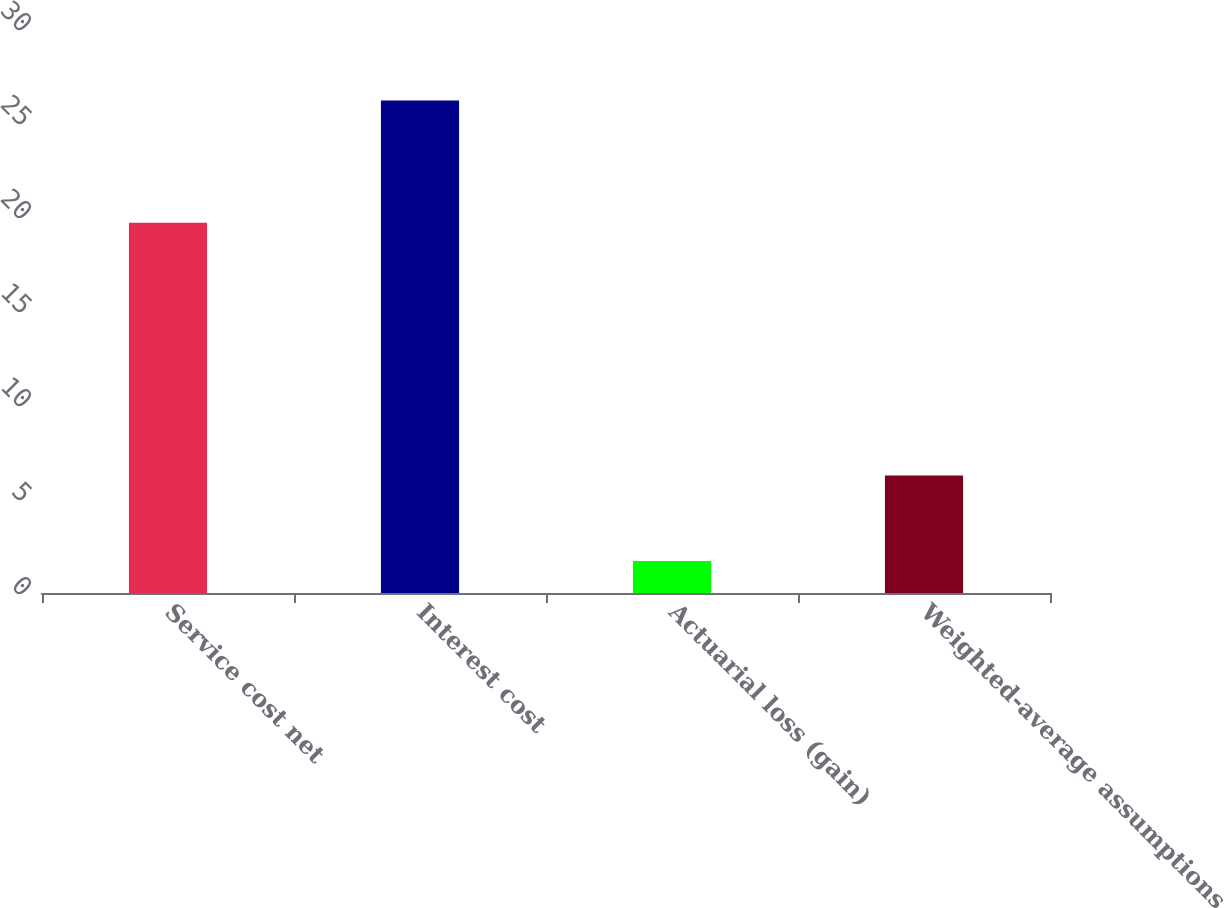Convert chart to OTSL. <chart><loc_0><loc_0><loc_500><loc_500><bar_chart><fcel>Service cost net<fcel>Interest cost<fcel>Actuarial loss (gain)<fcel>Weighted-average assumptions<nl><fcel>19.7<fcel>26.2<fcel>1.7<fcel>6.25<nl></chart> 